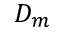Convert formula to latex. <formula><loc_0><loc_0><loc_500><loc_500>D _ { m }</formula> 